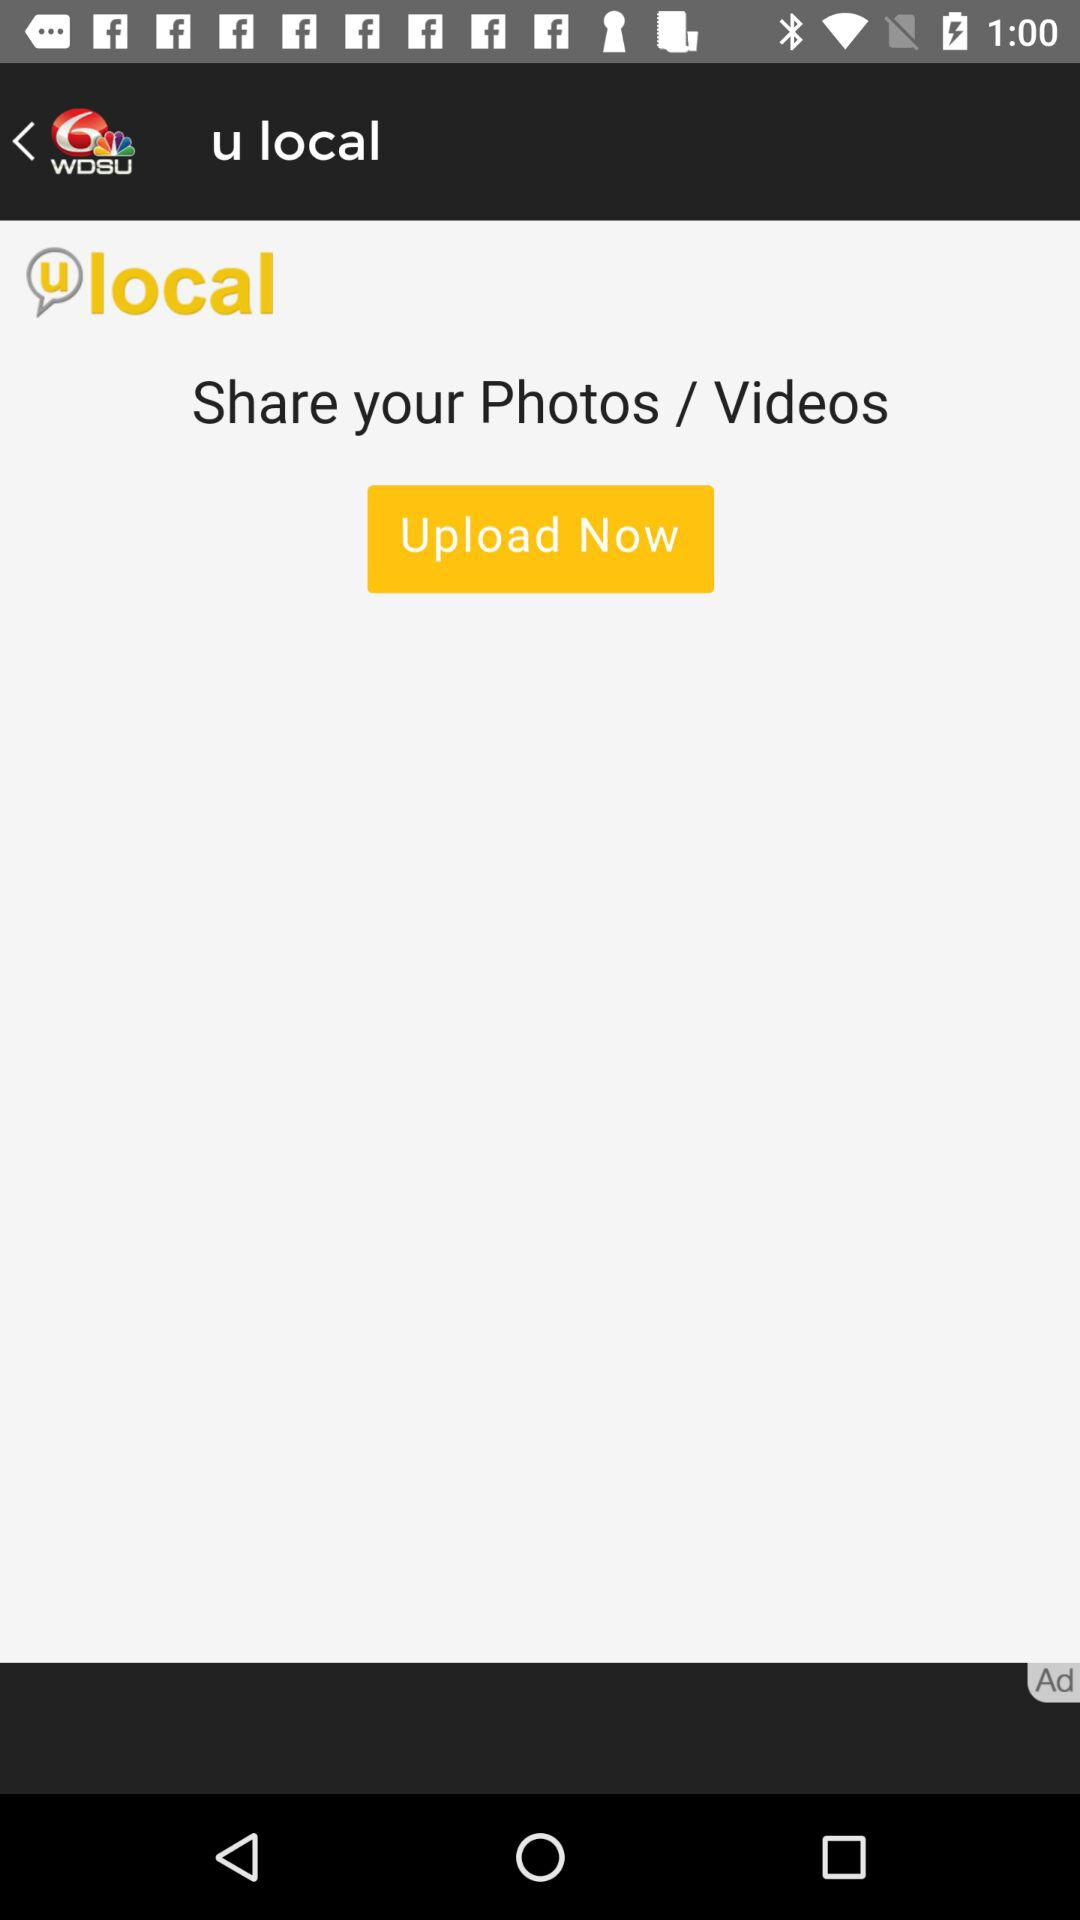How many photos have been uploaded?
When the provided information is insufficient, respond with <no answer>. <no answer> 